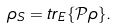<formula> <loc_0><loc_0><loc_500><loc_500>\rho _ { S } = { t r } _ { E } \{ { \mathcal { P } } \rho \} .</formula> 